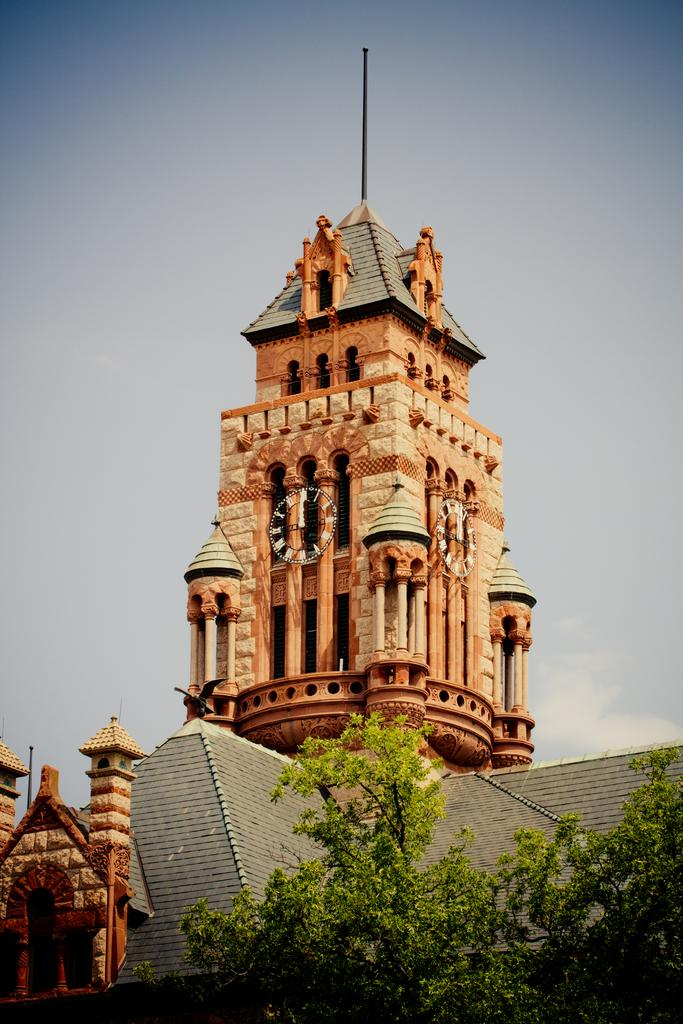What is the main structure in the image? There is a clock tower in the image. What can be seen at the bottom of the image? There are trees and roofs at the bottom of the image. What is visible at the top of the image? The sky is visible at the top of the image. What type of wool can be seen on the pigs in the image? There are no pigs or wool present in the image. How is the key used to unlock the clock tower in the image? There is no key or locking mechanism present in the image; it is a clock tower. 